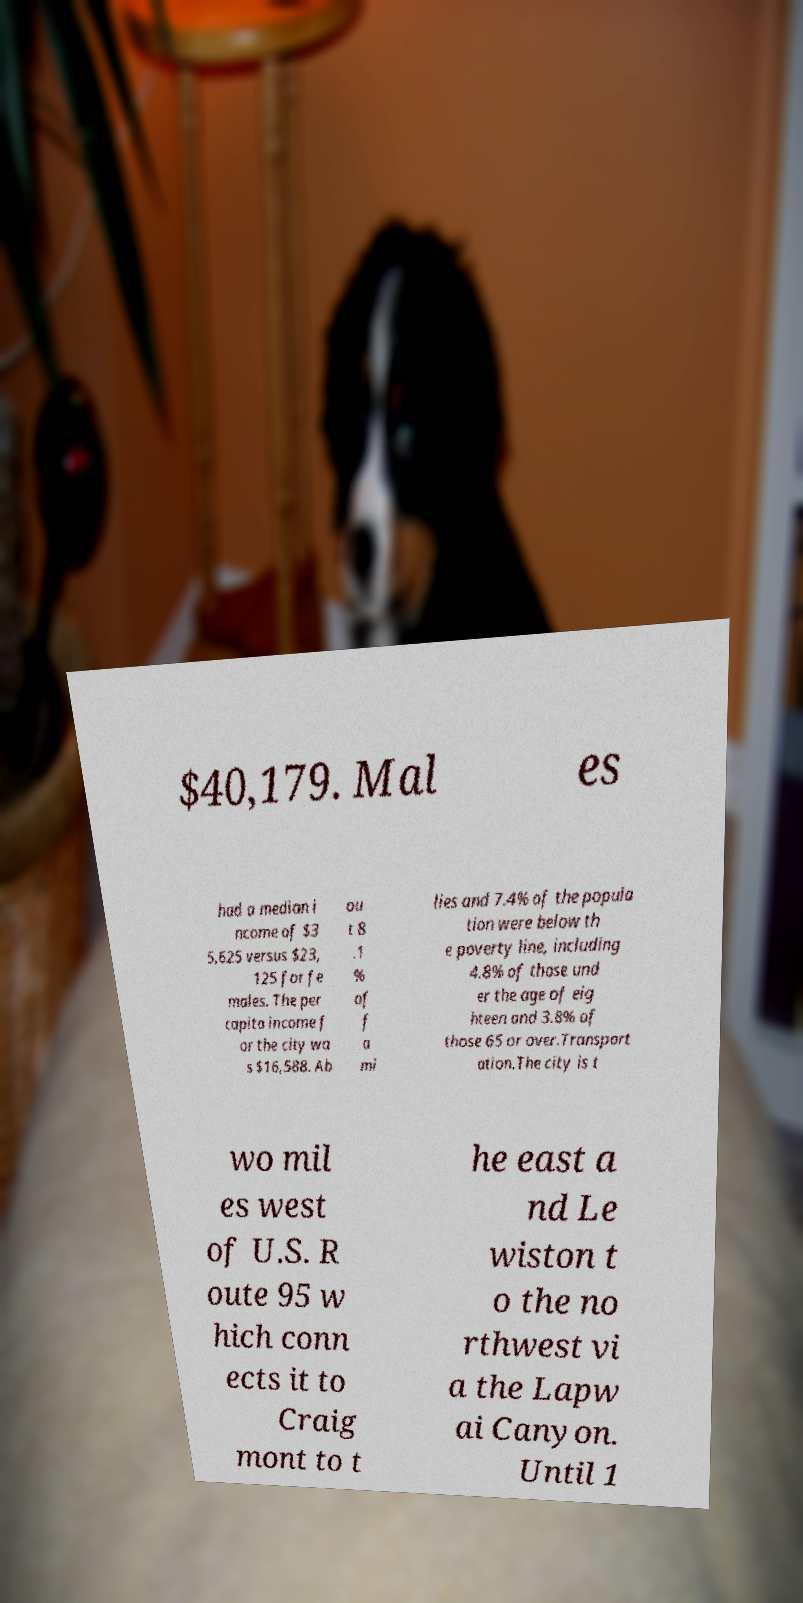Please read and relay the text visible in this image. What does it say? $40,179. Mal es had a median i ncome of $3 5,625 versus $23, 125 for fe males. The per capita income f or the city wa s $16,588. Ab ou t 8 .1 % of f a mi lies and 7.4% of the popula tion were below th e poverty line, including 4.8% of those und er the age of eig hteen and 3.8% of those 65 or over.Transport ation.The city is t wo mil es west of U.S. R oute 95 w hich conn ects it to Craig mont to t he east a nd Le wiston t o the no rthwest vi a the Lapw ai Canyon. Until 1 